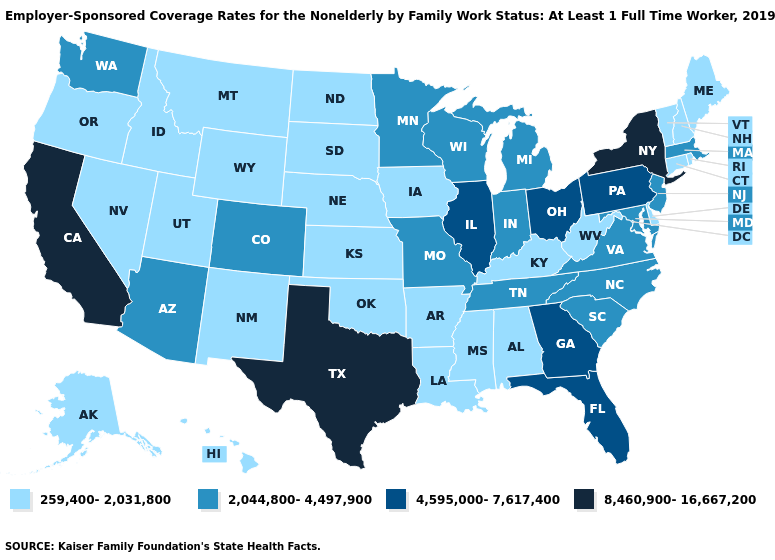What is the highest value in the MidWest ?
Be succinct. 4,595,000-7,617,400. Does the first symbol in the legend represent the smallest category?
Write a very short answer. Yes. Which states hav the highest value in the South?
Give a very brief answer. Texas. Which states have the lowest value in the Northeast?
Keep it brief. Connecticut, Maine, New Hampshire, Rhode Island, Vermont. Among the states that border New York , which have the highest value?
Quick response, please. Pennsylvania. Does Alabama have the lowest value in the USA?
Keep it brief. Yes. Does the first symbol in the legend represent the smallest category?
Answer briefly. Yes. Is the legend a continuous bar?
Quick response, please. No. What is the lowest value in the USA?
Answer briefly. 259,400-2,031,800. What is the value of New York?
Write a very short answer. 8,460,900-16,667,200. Which states hav the highest value in the Northeast?
Be succinct. New York. What is the lowest value in the South?
Keep it brief. 259,400-2,031,800. Name the states that have a value in the range 259,400-2,031,800?
Concise answer only. Alabama, Alaska, Arkansas, Connecticut, Delaware, Hawaii, Idaho, Iowa, Kansas, Kentucky, Louisiana, Maine, Mississippi, Montana, Nebraska, Nevada, New Hampshire, New Mexico, North Dakota, Oklahoma, Oregon, Rhode Island, South Dakota, Utah, Vermont, West Virginia, Wyoming. Does Hawaii have the same value as New Jersey?
Concise answer only. No. Among the states that border Illinois , which have the lowest value?
Be succinct. Iowa, Kentucky. 